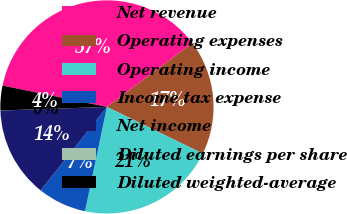Convert chart. <chart><loc_0><loc_0><loc_500><loc_500><pie_chart><fcel>Net revenue<fcel>Operating expenses<fcel>Operating income<fcel>Income tax expense<fcel>Net income<fcel>Diluted earnings per share<fcel>Diluted weighted-average<nl><fcel>36.57%<fcel>17.43%<fcel>21.09%<fcel>7.39%<fcel>13.77%<fcel>0.01%<fcel>3.74%<nl></chart> 